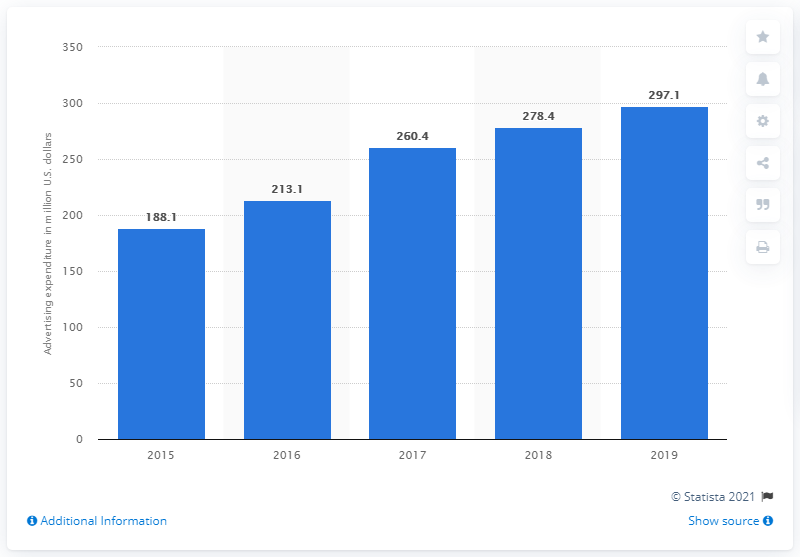Identify some key points in this picture. Skechers spent $297.1 million on advertising in the United States in 2019. 